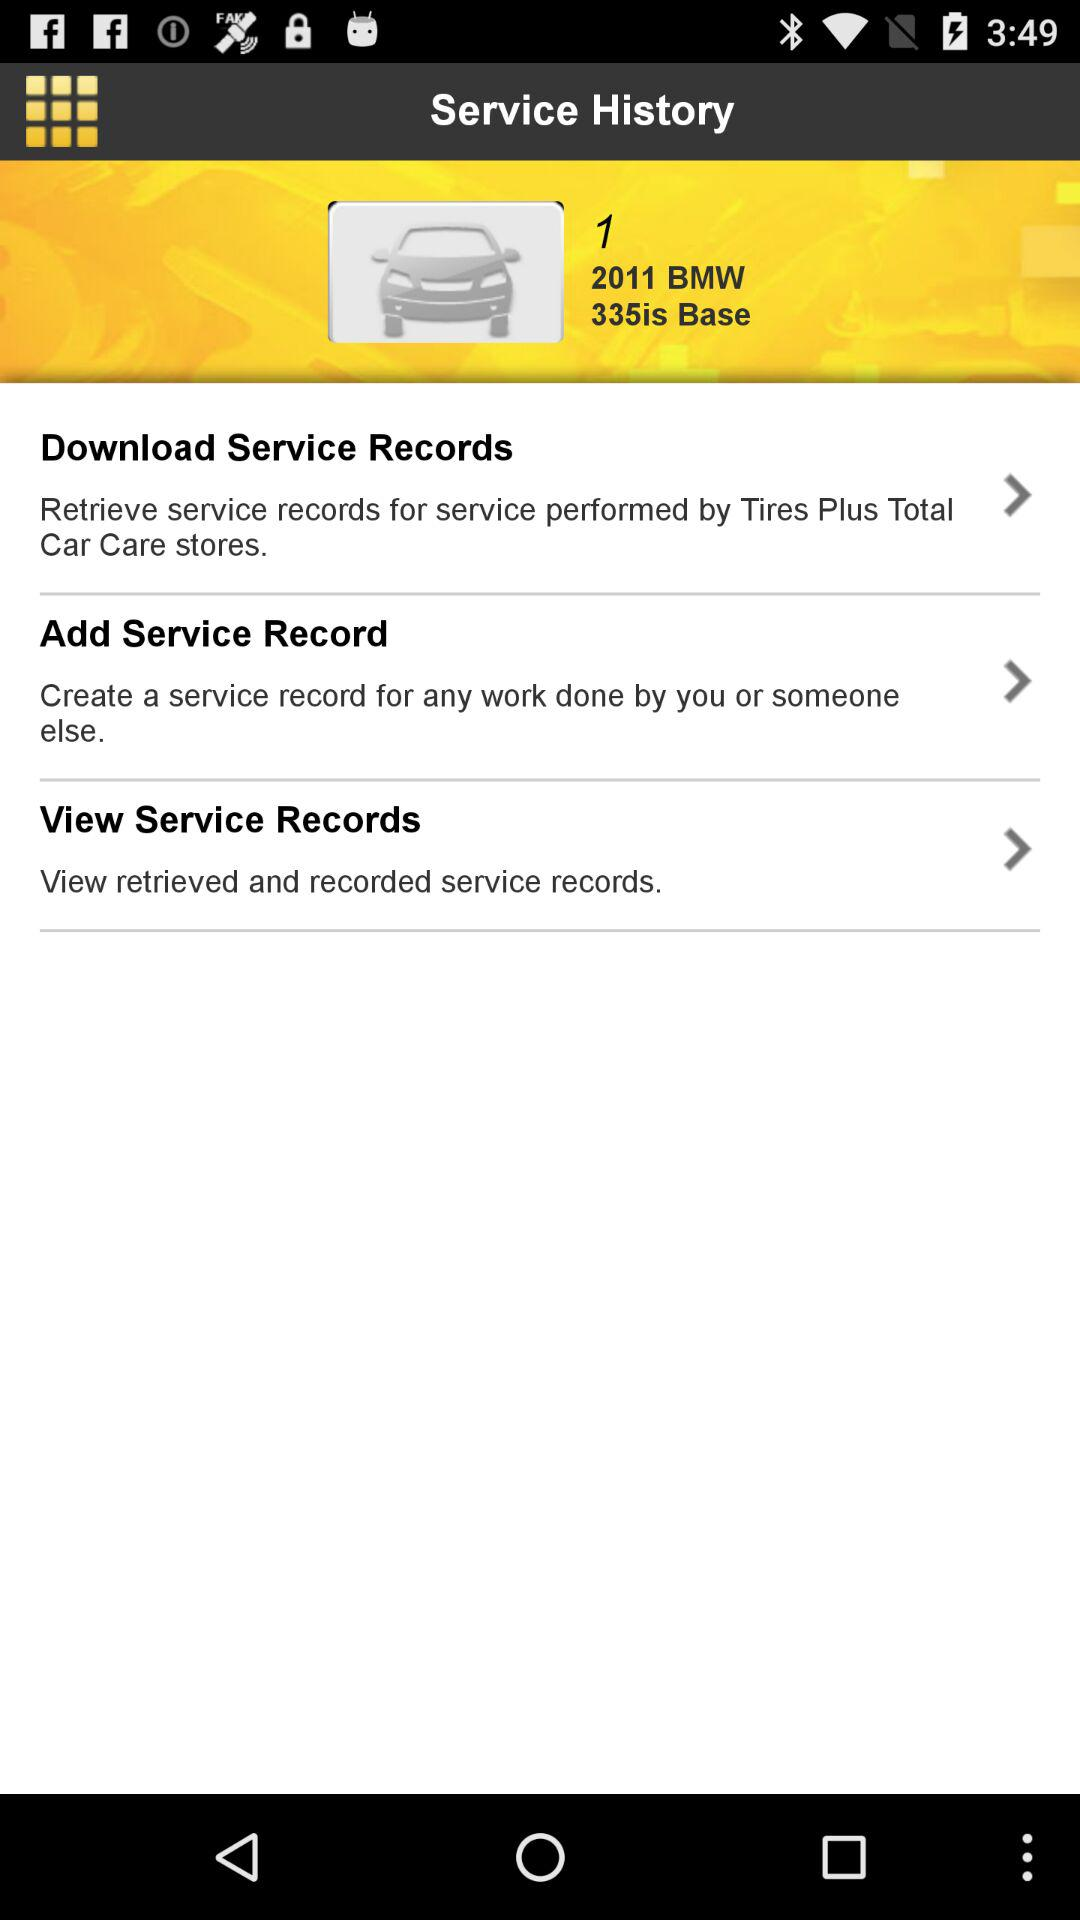How many service record options are available?
Answer the question using a single word or phrase. 3 